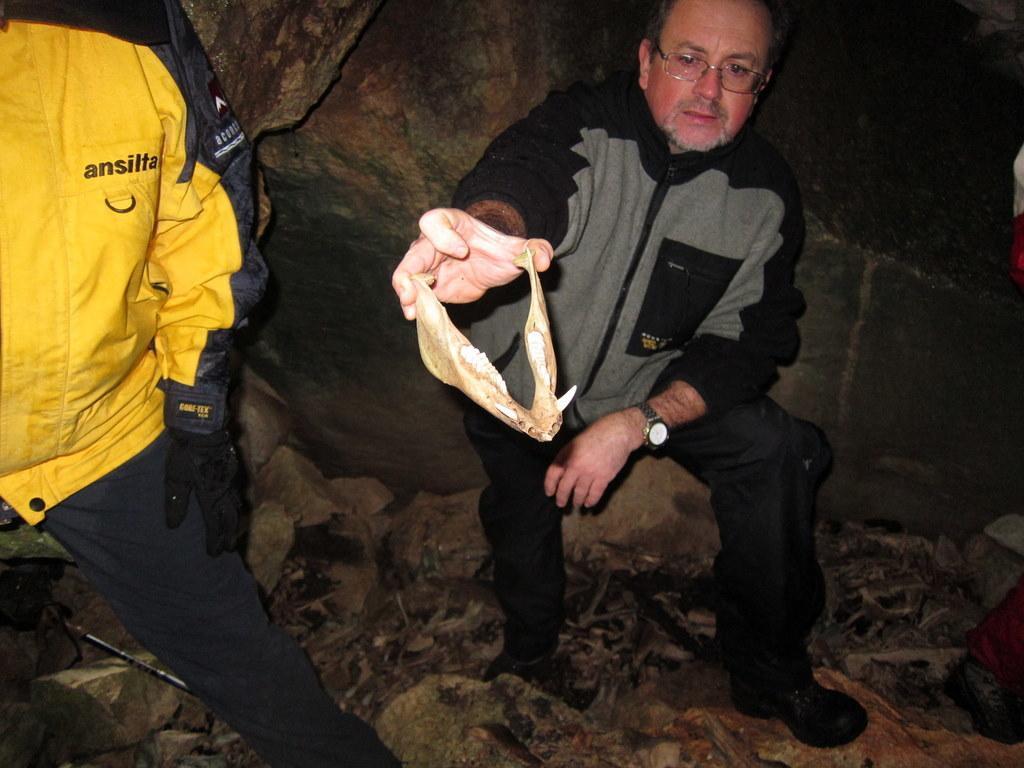Describe this image in one or two sentences. In the center of the image there is a person holding a object in his hand. To the left side of the image there is a person wearing yellow color jacket. At the bottom of the image there are rocks. In the background of the image there is a rock. 